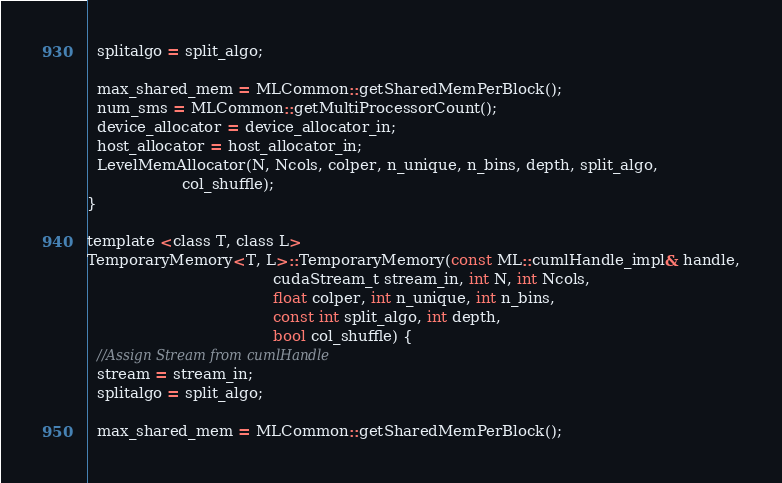<code> <loc_0><loc_0><loc_500><loc_500><_Cuda_>  splitalgo = split_algo;

  max_shared_mem = MLCommon::getSharedMemPerBlock();
  num_sms = MLCommon::getMultiProcessorCount();
  device_allocator = device_allocator_in;
  host_allocator = host_allocator_in;
  LevelMemAllocator(N, Ncols, colper, n_unique, n_bins, depth, split_algo,
                    col_shuffle);
}

template <class T, class L>
TemporaryMemory<T, L>::TemporaryMemory(const ML::cumlHandle_impl& handle,
                                       cudaStream_t stream_in, int N, int Ncols,
                                       float colper, int n_unique, int n_bins,
                                       const int split_algo, int depth,
                                       bool col_shuffle) {
  //Assign Stream from cumlHandle
  stream = stream_in;
  splitalgo = split_algo;

  max_shared_mem = MLCommon::getSharedMemPerBlock();</code> 